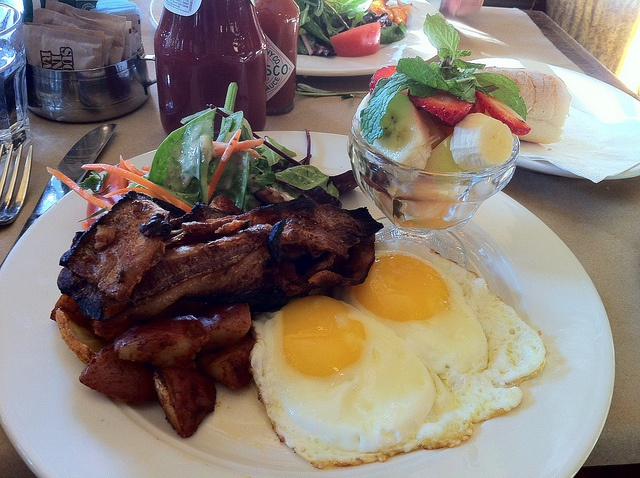Describe the objects in this image and their specific colors. I can see dining table in lightblue, gray, and black tones, bottle in lightblue, black, and purple tones, bowl in lightblue, darkgray, gray, and tan tones, cup in lightblue, gray, black, and navy tones, and bottle in lightblue, brown, purple, and black tones in this image. 